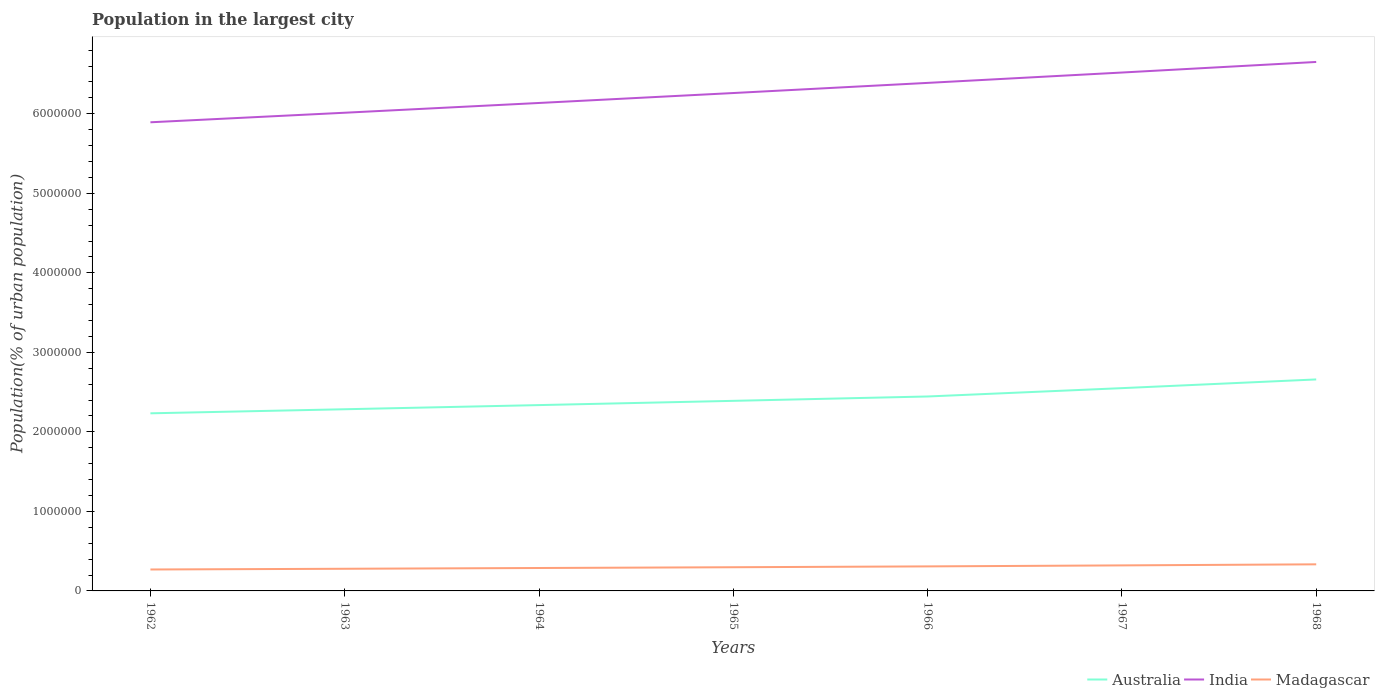Is the number of lines equal to the number of legend labels?
Your response must be concise. Yes. Across all years, what is the maximum population in the largest city in Madagascar?
Provide a short and direct response. 2.70e+05. In which year was the population in the largest city in Madagascar maximum?
Ensure brevity in your answer.  1962. What is the total population in the largest city in Australia in the graph?
Keep it short and to the point. -2.13e+05. What is the difference between the highest and the second highest population in the largest city in Madagascar?
Make the answer very short. 6.49e+04. What is the difference between the highest and the lowest population in the largest city in Australia?
Ensure brevity in your answer.  3. What is the difference between two consecutive major ticks on the Y-axis?
Provide a succinct answer. 1.00e+06. Does the graph contain any zero values?
Give a very brief answer. No. How many legend labels are there?
Your answer should be very brief. 3. What is the title of the graph?
Your response must be concise. Population in the largest city. Does "Sint Maarten (Dutch part)" appear as one of the legend labels in the graph?
Your answer should be compact. No. What is the label or title of the Y-axis?
Your response must be concise. Population(% of urban population). What is the Population(% of urban population) of Australia in 1962?
Offer a terse response. 2.23e+06. What is the Population(% of urban population) in India in 1962?
Your answer should be very brief. 5.89e+06. What is the Population(% of urban population) of Madagascar in 1962?
Offer a very short reply. 2.70e+05. What is the Population(% of urban population) in Australia in 1963?
Your response must be concise. 2.28e+06. What is the Population(% of urban population) of India in 1963?
Your answer should be compact. 6.01e+06. What is the Population(% of urban population) in Madagascar in 1963?
Offer a very short reply. 2.79e+05. What is the Population(% of urban population) in Australia in 1964?
Provide a succinct answer. 2.34e+06. What is the Population(% of urban population) of India in 1964?
Ensure brevity in your answer.  6.14e+06. What is the Population(% of urban population) in Madagascar in 1964?
Keep it short and to the point. 2.88e+05. What is the Population(% of urban population) in Australia in 1965?
Offer a terse response. 2.39e+06. What is the Population(% of urban population) in India in 1965?
Keep it short and to the point. 6.26e+06. What is the Population(% of urban population) in Madagascar in 1965?
Your answer should be compact. 2.98e+05. What is the Population(% of urban population) in Australia in 1966?
Give a very brief answer. 2.45e+06. What is the Population(% of urban population) in India in 1966?
Keep it short and to the point. 6.39e+06. What is the Population(% of urban population) of Madagascar in 1966?
Provide a succinct answer. 3.08e+05. What is the Population(% of urban population) in Australia in 1967?
Keep it short and to the point. 2.55e+06. What is the Population(% of urban population) of India in 1967?
Provide a succinct answer. 6.52e+06. What is the Population(% of urban population) of Madagascar in 1967?
Your response must be concise. 3.21e+05. What is the Population(% of urban population) of Australia in 1968?
Offer a terse response. 2.66e+06. What is the Population(% of urban population) of India in 1968?
Give a very brief answer. 6.65e+06. What is the Population(% of urban population) of Madagascar in 1968?
Your response must be concise. 3.34e+05. Across all years, what is the maximum Population(% of urban population) of Australia?
Offer a very short reply. 2.66e+06. Across all years, what is the maximum Population(% of urban population) in India?
Offer a very short reply. 6.65e+06. Across all years, what is the maximum Population(% of urban population) in Madagascar?
Offer a very short reply. 3.34e+05. Across all years, what is the minimum Population(% of urban population) in Australia?
Offer a terse response. 2.23e+06. Across all years, what is the minimum Population(% of urban population) of India?
Provide a short and direct response. 5.89e+06. Across all years, what is the minimum Population(% of urban population) of Madagascar?
Ensure brevity in your answer.  2.70e+05. What is the total Population(% of urban population) in Australia in the graph?
Offer a very short reply. 1.69e+07. What is the total Population(% of urban population) in India in the graph?
Your answer should be compact. 4.39e+07. What is the total Population(% of urban population) of Madagascar in the graph?
Offer a very short reply. 2.10e+06. What is the difference between the Population(% of urban population) in Australia in 1962 and that in 1963?
Offer a terse response. -5.11e+04. What is the difference between the Population(% of urban population) of India in 1962 and that in 1963?
Your answer should be compact. -1.20e+05. What is the difference between the Population(% of urban population) in Madagascar in 1962 and that in 1963?
Make the answer very short. -9164. What is the difference between the Population(% of urban population) of Australia in 1962 and that in 1964?
Give a very brief answer. -1.03e+05. What is the difference between the Population(% of urban population) in India in 1962 and that in 1964?
Your response must be concise. -2.43e+05. What is the difference between the Population(% of urban population) in Madagascar in 1962 and that in 1964?
Make the answer very short. -1.87e+04. What is the difference between the Population(% of urban population) in Australia in 1962 and that in 1965?
Ensure brevity in your answer.  -1.57e+05. What is the difference between the Population(% of urban population) of India in 1962 and that in 1965?
Your answer should be compact. -3.68e+05. What is the difference between the Population(% of urban population) of Madagascar in 1962 and that in 1965?
Provide a short and direct response. -2.84e+04. What is the difference between the Population(% of urban population) of Australia in 1962 and that in 1966?
Provide a succinct answer. -2.12e+05. What is the difference between the Population(% of urban population) in India in 1962 and that in 1966?
Your answer should be very brief. -4.95e+05. What is the difference between the Population(% of urban population) of Madagascar in 1962 and that in 1966?
Make the answer very short. -3.89e+04. What is the difference between the Population(% of urban population) in Australia in 1962 and that in 1967?
Your response must be concise. -3.16e+05. What is the difference between the Population(% of urban population) of India in 1962 and that in 1967?
Make the answer very short. -6.26e+05. What is the difference between the Population(% of urban population) of Madagascar in 1962 and that in 1967?
Provide a succinct answer. -5.16e+04. What is the difference between the Population(% of urban population) of Australia in 1962 and that in 1968?
Offer a terse response. -4.26e+05. What is the difference between the Population(% of urban population) in India in 1962 and that in 1968?
Ensure brevity in your answer.  -7.59e+05. What is the difference between the Population(% of urban population) of Madagascar in 1962 and that in 1968?
Your answer should be very brief. -6.49e+04. What is the difference between the Population(% of urban population) in Australia in 1963 and that in 1964?
Your answer should be compact. -5.23e+04. What is the difference between the Population(% of urban population) of India in 1963 and that in 1964?
Provide a short and direct response. -1.23e+05. What is the difference between the Population(% of urban population) in Madagascar in 1963 and that in 1964?
Give a very brief answer. -9490. What is the difference between the Population(% of urban population) of Australia in 1963 and that in 1965?
Your response must be concise. -1.06e+05. What is the difference between the Population(% of urban population) in India in 1963 and that in 1965?
Make the answer very short. -2.48e+05. What is the difference between the Population(% of urban population) of Madagascar in 1963 and that in 1965?
Give a very brief answer. -1.93e+04. What is the difference between the Population(% of urban population) in Australia in 1963 and that in 1966?
Provide a short and direct response. -1.60e+05. What is the difference between the Population(% of urban population) in India in 1963 and that in 1966?
Keep it short and to the point. -3.75e+05. What is the difference between the Population(% of urban population) in Madagascar in 1963 and that in 1966?
Make the answer very short. -2.97e+04. What is the difference between the Population(% of urban population) in Australia in 1963 and that in 1967?
Give a very brief answer. -2.65e+05. What is the difference between the Population(% of urban population) in India in 1963 and that in 1967?
Your answer should be compact. -5.05e+05. What is the difference between the Population(% of urban population) in Madagascar in 1963 and that in 1967?
Ensure brevity in your answer.  -4.25e+04. What is the difference between the Population(% of urban population) of Australia in 1963 and that in 1968?
Your answer should be compact. -3.75e+05. What is the difference between the Population(% of urban population) in India in 1963 and that in 1968?
Offer a terse response. -6.39e+05. What is the difference between the Population(% of urban population) in Madagascar in 1963 and that in 1968?
Ensure brevity in your answer.  -5.58e+04. What is the difference between the Population(% of urban population) of Australia in 1964 and that in 1965?
Offer a very short reply. -5.34e+04. What is the difference between the Population(% of urban population) of India in 1964 and that in 1965?
Your response must be concise. -1.25e+05. What is the difference between the Population(% of urban population) of Madagascar in 1964 and that in 1965?
Make the answer very short. -9785. What is the difference between the Population(% of urban population) of Australia in 1964 and that in 1966?
Make the answer very short. -1.08e+05. What is the difference between the Population(% of urban population) of India in 1964 and that in 1966?
Your answer should be very brief. -2.53e+05. What is the difference between the Population(% of urban population) of Madagascar in 1964 and that in 1966?
Give a very brief answer. -2.02e+04. What is the difference between the Population(% of urban population) in Australia in 1964 and that in 1967?
Offer a very short reply. -2.13e+05. What is the difference between the Population(% of urban population) in India in 1964 and that in 1967?
Make the answer very short. -3.83e+05. What is the difference between the Population(% of urban population) in Madagascar in 1964 and that in 1967?
Offer a terse response. -3.30e+04. What is the difference between the Population(% of urban population) of Australia in 1964 and that in 1968?
Give a very brief answer. -3.23e+05. What is the difference between the Population(% of urban population) of India in 1964 and that in 1968?
Provide a short and direct response. -5.16e+05. What is the difference between the Population(% of urban population) of Madagascar in 1964 and that in 1968?
Provide a succinct answer. -4.63e+04. What is the difference between the Population(% of urban population) in Australia in 1965 and that in 1966?
Keep it short and to the point. -5.48e+04. What is the difference between the Population(% of urban population) in India in 1965 and that in 1966?
Offer a very short reply. -1.28e+05. What is the difference between the Population(% of urban population) in Madagascar in 1965 and that in 1966?
Offer a very short reply. -1.04e+04. What is the difference between the Population(% of urban population) of Australia in 1965 and that in 1967?
Keep it short and to the point. -1.60e+05. What is the difference between the Population(% of urban population) of India in 1965 and that in 1967?
Offer a terse response. -2.58e+05. What is the difference between the Population(% of urban population) of Madagascar in 1965 and that in 1967?
Ensure brevity in your answer.  -2.32e+04. What is the difference between the Population(% of urban population) in Australia in 1965 and that in 1968?
Offer a terse response. -2.69e+05. What is the difference between the Population(% of urban population) of India in 1965 and that in 1968?
Make the answer very short. -3.91e+05. What is the difference between the Population(% of urban population) in Madagascar in 1965 and that in 1968?
Ensure brevity in your answer.  -3.65e+04. What is the difference between the Population(% of urban population) in Australia in 1966 and that in 1967?
Offer a terse response. -1.05e+05. What is the difference between the Population(% of urban population) of India in 1966 and that in 1967?
Keep it short and to the point. -1.30e+05. What is the difference between the Population(% of urban population) in Madagascar in 1966 and that in 1967?
Keep it short and to the point. -1.27e+04. What is the difference between the Population(% of urban population) in Australia in 1966 and that in 1968?
Keep it short and to the point. -2.14e+05. What is the difference between the Population(% of urban population) of India in 1966 and that in 1968?
Make the answer very short. -2.63e+05. What is the difference between the Population(% of urban population) of Madagascar in 1966 and that in 1968?
Provide a short and direct response. -2.60e+04. What is the difference between the Population(% of urban population) in Australia in 1967 and that in 1968?
Your response must be concise. -1.10e+05. What is the difference between the Population(% of urban population) of India in 1967 and that in 1968?
Offer a terse response. -1.33e+05. What is the difference between the Population(% of urban population) of Madagascar in 1967 and that in 1968?
Your response must be concise. -1.33e+04. What is the difference between the Population(% of urban population) of Australia in 1962 and the Population(% of urban population) of India in 1963?
Provide a succinct answer. -3.78e+06. What is the difference between the Population(% of urban population) of Australia in 1962 and the Population(% of urban population) of Madagascar in 1963?
Your answer should be very brief. 1.95e+06. What is the difference between the Population(% of urban population) in India in 1962 and the Population(% of urban population) in Madagascar in 1963?
Provide a short and direct response. 5.61e+06. What is the difference between the Population(% of urban population) in Australia in 1962 and the Population(% of urban population) in India in 1964?
Ensure brevity in your answer.  -3.90e+06. What is the difference between the Population(% of urban population) in Australia in 1962 and the Population(% of urban population) in Madagascar in 1964?
Make the answer very short. 1.95e+06. What is the difference between the Population(% of urban population) of India in 1962 and the Population(% of urban population) of Madagascar in 1964?
Ensure brevity in your answer.  5.61e+06. What is the difference between the Population(% of urban population) of Australia in 1962 and the Population(% of urban population) of India in 1965?
Your answer should be very brief. -4.03e+06. What is the difference between the Population(% of urban population) of Australia in 1962 and the Population(% of urban population) of Madagascar in 1965?
Give a very brief answer. 1.94e+06. What is the difference between the Population(% of urban population) in India in 1962 and the Population(% of urban population) in Madagascar in 1965?
Offer a terse response. 5.60e+06. What is the difference between the Population(% of urban population) of Australia in 1962 and the Population(% of urban population) of India in 1966?
Keep it short and to the point. -4.16e+06. What is the difference between the Population(% of urban population) of Australia in 1962 and the Population(% of urban population) of Madagascar in 1966?
Offer a very short reply. 1.93e+06. What is the difference between the Population(% of urban population) in India in 1962 and the Population(% of urban population) in Madagascar in 1966?
Offer a terse response. 5.58e+06. What is the difference between the Population(% of urban population) of Australia in 1962 and the Population(% of urban population) of India in 1967?
Your answer should be very brief. -4.29e+06. What is the difference between the Population(% of urban population) of Australia in 1962 and the Population(% of urban population) of Madagascar in 1967?
Ensure brevity in your answer.  1.91e+06. What is the difference between the Population(% of urban population) of India in 1962 and the Population(% of urban population) of Madagascar in 1967?
Offer a very short reply. 5.57e+06. What is the difference between the Population(% of urban population) of Australia in 1962 and the Population(% of urban population) of India in 1968?
Offer a terse response. -4.42e+06. What is the difference between the Population(% of urban population) of Australia in 1962 and the Population(% of urban population) of Madagascar in 1968?
Make the answer very short. 1.90e+06. What is the difference between the Population(% of urban population) of India in 1962 and the Population(% of urban population) of Madagascar in 1968?
Your answer should be very brief. 5.56e+06. What is the difference between the Population(% of urban population) in Australia in 1963 and the Population(% of urban population) in India in 1964?
Your response must be concise. -3.85e+06. What is the difference between the Population(% of urban population) in Australia in 1963 and the Population(% of urban population) in Madagascar in 1964?
Provide a succinct answer. 2.00e+06. What is the difference between the Population(% of urban population) in India in 1963 and the Population(% of urban population) in Madagascar in 1964?
Your answer should be very brief. 5.73e+06. What is the difference between the Population(% of urban population) of Australia in 1963 and the Population(% of urban population) of India in 1965?
Your answer should be compact. -3.98e+06. What is the difference between the Population(% of urban population) of Australia in 1963 and the Population(% of urban population) of Madagascar in 1965?
Keep it short and to the point. 1.99e+06. What is the difference between the Population(% of urban population) in India in 1963 and the Population(% of urban population) in Madagascar in 1965?
Make the answer very short. 5.72e+06. What is the difference between the Population(% of urban population) in Australia in 1963 and the Population(% of urban population) in India in 1966?
Provide a succinct answer. -4.10e+06. What is the difference between the Population(% of urban population) of Australia in 1963 and the Population(% of urban population) of Madagascar in 1966?
Make the answer very short. 1.98e+06. What is the difference between the Population(% of urban population) in India in 1963 and the Population(% of urban population) in Madagascar in 1966?
Give a very brief answer. 5.70e+06. What is the difference between the Population(% of urban population) of Australia in 1963 and the Population(% of urban population) of India in 1967?
Keep it short and to the point. -4.23e+06. What is the difference between the Population(% of urban population) of Australia in 1963 and the Population(% of urban population) of Madagascar in 1967?
Give a very brief answer. 1.96e+06. What is the difference between the Population(% of urban population) of India in 1963 and the Population(% of urban population) of Madagascar in 1967?
Your answer should be compact. 5.69e+06. What is the difference between the Population(% of urban population) of Australia in 1963 and the Population(% of urban population) of India in 1968?
Offer a very short reply. -4.37e+06. What is the difference between the Population(% of urban population) in Australia in 1963 and the Population(% of urban population) in Madagascar in 1968?
Ensure brevity in your answer.  1.95e+06. What is the difference between the Population(% of urban population) of India in 1963 and the Population(% of urban population) of Madagascar in 1968?
Provide a succinct answer. 5.68e+06. What is the difference between the Population(% of urban population) in Australia in 1964 and the Population(% of urban population) in India in 1965?
Keep it short and to the point. -3.92e+06. What is the difference between the Population(% of urban population) in Australia in 1964 and the Population(% of urban population) in Madagascar in 1965?
Your answer should be very brief. 2.04e+06. What is the difference between the Population(% of urban population) in India in 1964 and the Population(% of urban population) in Madagascar in 1965?
Provide a short and direct response. 5.84e+06. What is the difference between the Population(% of urban population) in Australia in 1964 and the Population(% of urban population) in India in 1966?
Your answer should be very brief. -4.05e+06. What is the difference between the Population(% of urban population) in Australia in 1964 and the Population(% of urban population) in Madagascar in 1966?
Offer a terse response. 2.03e+06. What is the difference between the Population(% of urban population) of India in 1964 and the Population(% of urban population) of Madagascar in 1966?
Your answer should be compact. 5.83e+06. What is the difference between the Population(% of urban population) of Australia in 1964 and the Population(% of urban population) of India in 1967?
Make the answer very short. -4.18e+06. What is the difference between the Population(% of urban population) in Australia in 1964 and the Population(% of urban population) in Madagascar in 1967?
Provide a succinct answer. 2.02e+06. What is the difference between the Population(% of urban population) in India in 1964 and the Population(% of urban population) in Madagascar in 1967?
Give a very brief answer. 5.81e+06. What is the difference between the Population(% of urban population) of Australia in 1964 and the Population(% of urban population) of India in 1968?
Offer a terse response. -4.32e+06. What is the difference between the Population(% of urban population) of Australia in 1964 and the Population(% of urban population) of Madagascar in 1968?
Offer a terse response. 2.00e+06. What is the difference between the Population(% of urban population) in India in 1964 and the Population(% of urban population) in Madagascar in 1968?
Your answer should be compact. 5.80e+06. What is the difference between the Population(% of urban population) of Australia in 1965 and the Population(% of urban population) of India in 1966?
Ensure brevity in your answer.  -4.00e+06. What is the difference between the Population(% of urban population) of Australia in 1965 and the Population(% of urban population) of Madagascar in 1966?
Offer a terse response. 2.08e+06. What is the difference between the Population(% of urban population) of India in 1965 and the Population(% of urban population) of Madagascar in 1966?
Give a very brief answer. 5.95e+06. What is the difference between the Population(% of urban population) of Australia in 1965 and the Population(% of urban population) of India in 1967?
Make the answer very short. -4.13e+06. What is the difference between the Population(% of urban population) of Australia in 1965 and the Population(% of urban population) of Madagascar in 1967?
Your answer should be very brief. 2.07e+06. What is the difference between the Population(% of urban population) of India in 1965 and the Population(% of urban population) of Madagascar in 1967?
Your answer should be compact. 5.94e+06. What is the difference between the Population(% of urban population) in Australia in 1965 and the Population(% of urban population) in India in 1968?
Give a very brief answer. -4.26e+06. What is the difference between the Population(% of urban population) of Australia in 1965 and the Population(% of urban population) of Madagascar in 1968?
Offer a very short reply. 2.06e+06. What is the difference between the Population(% of urban population) in India in 1965 and the Population(% of urban population) in Madagascar in 1968?
Your answer should be very brief. 5.93e+06. What is the difference between the Population(% of urban population) in Australia in 1966 and the Population(% of urban population) in India in 1967?
Keep it short and to the point. -4.07e+06. What is the difference between the Population(% of urban population) in Australia in 1966 and the Population(% of urban population) in Madagascar in 1967?
Provide a succinct answer. 2.12e+06. What is the difference between the Population(% of urban population) in India in 1966 and the Population(% of urban population) in Madagascar in 1967?
Make the answer very short. 6.07e+06. What is the difference between the Population(% of urban population) of Australia in 1966 and the Population(% of urban population) of India in 1968?
Offer a very short reply. -4.21e+06. What is the difference between the Population(% of urban population) in Australia in 1966 and the Population(% of urban population) in Madagascar in 1968?
Your response must be concise. 2.11e+06. What is the difference between the Population(% of urban population) of India in 1966 and the Population(% of urban population) of Madagascar in 1968?
Your answer should be compact. 6.05e+06. What is the difference between the Population(% of urban population) of Australia in 1967 and the Population(% of urban population) of India in 1968?
Keep it short and to the point. -4.10e+06. What is the difference between the Population(% of urban population) of Australia in 1967 and the Population(% of urban population) of Madagascar in 1968?
Provide a succinct answer. 2.22e+06. What is the difference between the Population(% of urban population) of India in 1967 and the Population(% of urban population) of Madagascar in 1968?
Keep it short and to the point. 6.18e+06. What is the average Population(% of urban population) of Australia per year?
Offer a terse response. 2.41e+06. What is the average Population(% of urban population) in India per year?
Ensure brevity in your answer.  6.27e+06. What is the average Population(% of urban population) of Madagascar per year?
Your response must be concise. 3.00e+05. In the year 1962, what is the difference between the Population(% of urban population) of Australia and Population(% of urban population) of India?
Make the answer very short. -3.66e+06. In the year 1962, what is the difference between the Population(% of urban population) of Australia and Population(% of urban population) of Madagascar?
Ensure brevity in your answer.  1.96e+06. In the year 1962, what is the difference between the Population(% of urban population) of India and Population(% of urban population) of Madagascar?
Provide a short and direct response. 5.62e+06. In the year 1963, what is the difference between the Population(% of urban population) of Australia and Population(% of urban population) of India?
Offer a very short reply. -3.73e+06. In the year 1963, what is the difference between the Population(% of urban population) in Australia and Population(% of urban population) in Madagascar?
Give a very brief answer. 2.01e+06. In the year 1963, what is the difference between the Population(% of urban population) of India and Population(% of urban population) of Madagascar?
Provide a succinct answer. 5.73e+06. In the year 1964, what is the difference between the Population(% of urban population) in Australia and Population(% of urban population) in India?
Offer a very short reply. -3.80e+06. In the year 1964, what is the difference between the Population(% of urban population) of Australia and Population(% of urban population) of Madagascar?
Ensure brevity in your answer.  2.05e+06. In the year 1964, what is the difference between the Population(% of urban population) in India and Population(% of urban population) in Madagascar?
Give a very brief answer. 5.85e+06. In the year 1965, what is the difference between the Population(% of urban population) of Australia and Population(% of urban population) of India?
Ensure brevity in your answer.  -3.87e+06. In the year 1965, what is the difference between the Population(% of urban population) in Australia and Population(% of urban population) in Madagascar?
Ensure brevity in your answer.  2.09e+06. In the year 1965, what is the difference between the Population(% of urban population) in India and Population(% of urban population) in Madagascar?
Your answer should be compact. 5.96e+06. In the year 1966, what is the difference between the Population(% of urban population) in Australia and Population(% of urban population) in India?
Ensure brevity in your answer.  -3.94e+06. In the year 1966, what is the difference between the Population(% of urban population) in Australia and Population(% of urban population) in Madagascar?
Give a very brief answer. 2.14e+06. In the year 1966, what is the difference between the Population(% of urban population) in India and Population(% of urban population) in Madagascar?
Make the answer very short. 6.08e+06. In the year 1967, what is the difference between the Population(% of urban population) in Australia and Population(% of urban population) in India?
Offer a very short reply. -3.97e+06. In the year 1967, what is the difference between the Population(% of urban population) in Australia and Population(% of urban population) in Madagascar?
Your response must be concise. 2.23e+06. In the year 1967, what is the difference between the Population(% of urban population) of India and Population(% of urban population) of Madagascar?
Your answer should be very brief. 6.20e+06. In the year 1968, what is the difference between the Population(% of urban population) of Australia and Population(% of urban population) of India?
Keep it short and to the point. -3.99e+06. In the year 1968, what is the difference between the Population(% of urban population) in Australia and Population(% of urban population) in Madagascar?
Make the answer very short. 2.33e+06. In the year 1968, what is the difference between the Population(% of urban population) of India and Population(% of urban population) of Madagascar?
Make the answer very short. 6.32e+06. What is the ratio of the Population(% of urban population) of Australia in 1962 to that in 1963?
Provide a short and direct response. 0.98. What is the ratio of the Population(% of urban population) of India in 1962 to that in 1963?
Ensure brevity in your answer.  0.98. What is the ratio of the Population(% of urban population) in Madagascar in 1962 to that in 1963?
Keep it short and to the point. 0.97. What is the ratio of the Population(% of urban population) of Australia in 1962 to that in 1964?
Your answer should be compact. 0.96. What is the ratio of the Population(% of urban population) of India in 1962 to that in 1964?
Your response must be concise. 0.96. What is the ratio of the Population(% of urban population) of Madagascar in 1962 to that in 1964?
Offer a terse response. 0.94. What is the ratio of the Population(% of urban population) of Australia in 1962 to that in 1965?
Offer a very short reply. 0.93. What is the ratio of the Population(% of urban population) of India in 1962 to that in 1965?
Provide a short and direct response. 0.94. What is the ratio of the Population(% of urban population) of Madagascar in 1962 to that in 1965?
Offer a terse response. 0.9. What is the ratio of the Population(% of urban population) of Australia in 1962 to that in 1966?
Keep it short and to the point. 0.91. What is the ratio of the Population(% of urban population) of India in 1962 to that in 1966?
Provide a short and direct response. 0.92. What is the ratio of the Population(% of urban population) in Madagascar in 1962 to that in 1966?
Keep it short and to the point. 0.87. What is the ratio of the Population(% of urban population) in Australia in 1962 to that in 1967?
Your answer should be compact. 0.88. What is the ratio of the Population(% of urban population) in India in 1962 to that in 1967?
Your answer should be compact. 0.9. What is the ratio of the Population(% of urban population) in Madagascar in 1962 to that in 1967?
Your response must be concise. 0.84. What is the ratio of the Population(% of urban population) of Australia in 1962 to that in 1968?
Your response must be concise. 0.84. What is the ratio of the Population(% of urban population) in India in 1962 to that in 1968?
Offer a terse response. 0.89. What is the ratio of the Population(% of urban population) in Madagascar in 1962 to that in 1968?
Keep it short and to the point. 0.81. What is the ratio of the Population(% of urban population) in Australia in 1963 to that in 1964?
Your response must be concise. 0.98. What is the ratio of the Population(% of urban population) in Madagascar in 1963 to that in 1964?
Your answer should be very brief. 0.97. What is the ratio of the Population(% of urban population) in Australia in 1963 to that in 1965?
Your response must be concise. 0.96. What is the ratio of the Population(% of urban population) in India in 1963 to that in 1965?
Your answer should be compact. 0.96. What is the ratio of the Population(% of urban population) of Madagascar in 1963 to that in 1965?
Provide a succinct answer. 0.94. What is the ratio of the Population(% of urban population) in Australia in 1963 to that in 1966?
Provide a short and direct response. 0.93. What is the ratio of the Population(% of urban population) of India in 1963 to that in 1966?
Provide a short and direct response. 0.94. What is the ratio of the Population(% of urban population) of Madagascar in 1963 to that in 1966?
Provide a succinct answer. 0.9. What is the ratio of the Population(% of urban population) of Australia in 1963 to that in 1967?
Offer a very short reply. 0.9. What is the ratio of the Population(% of urban population) of India in 1963 to that in 1967?
Your answer should be very brief. 0.92. What is the ratio of the Population(% of urban population) of Madagascar in 1963 to that in 1967?
Your answer should be compact. 0.87. What is the ratio of the Population(% of urban population) in Australia in 1963 to that in 1968?
Your answer should be compact. 0.86. What is the ratio of the Population(% of urban population) in India in 1963 to that in 1968?
Provide a succinct answer. 0.9. What is the ratio of the Population(% of urban population) in Australia in 1964 to that in 1965?
Your answer should be compact. 0.98. What is the ratio of the Population(% of urban population) of India in 1964 to that in 1965?
Offer a very short reply. 0.98. What is the ratio of the Population(% of urban population) in Madagascar in 1964 to that in 1965?
Provide a short and direct response. 0.97. What is the ratio of the Population(% of urban population) in Australia in 1964 to that in 1966?
Your response must be concise. 0.96. What is the ratio of the Population(% of urban population) in India in 1964 to that in 1966?
Your answer should be compact. 0.96. What is the ratio of the Population(% of urban population) in Madagascar in 1964 to that in 1966?
Provide a short and direct response. 0.93. What is the ratio of the Population(% of urban population) of Australia in 1964 to that in 1967?
Your response must be concise. 0.92. What is the ratio of the Population(% of urban population) of India in 1964 to that in 1967?
Give a very brief answer. 0.94. What is the ratio of the Population(% of urban population) of Madagascar in 1964 to that in 1967?
Provide a short and direct response. 0.9. What is the ratio of the Population(% of urban population) in Australia in 1964 to that in 1968?
Your response must be concise. 0.88. What is the ratio of the Population(% of urban population) in India in 1964 to that in 1968?
Make the answer very short. 0.92. What is the ratio of the Population(% of urban population) in Madagascar in 1964 to that in 1968?
Your answer should be compact. 0.86. What is the ratio of the Population(% of urban population) in Australia in 1965 to that in 1966?
Keep it short and to the point. 0.98. What is the ratio of the Population(% of urban population) in India in 1965 to that in 1966?
Provide a succinct answer. 0.98. What is the ratio of the Population(% of urban population) of Madagascar in 1965 to that in 1966?
Provide a short and direct response. 0.97. What is the ratio of the Population(% of urban population) in Australia in 1965 to that in 1967?
Provide a succinct answer. 0.94. What is the ratio of the Population(% of urban population) of India in 1965 to that in 1967?
Your answer should be very brief. 0.96. What is the ratio of the Population(% of urban population) in Madagascar in 1965 to that in 1967?
Provide a succinct answer. 0.93. What is the ratio of the Population(% of urban population) in Australia in 1965 to that in 1968?
Your answer should be compact. 0.9. What is the ratio of the Population(% of urban population) of Madagascar in 1965 to that in 1968?
Your answer should be very brief. 0.89. What is the ratio of the Population(% of urban population) in Australia in 1966 to that in 1967?
Offer a very short reply. 0.96. What is the ratio of the Population(% of urban population) of Madagascar in 1966 to that in 1967?
Provide a succinct answer. 0.96. What is the ratio of the Population(% of urban population) in Australia in 1966 to that in 1968?
Give a very brief answer. 0.92. What is the ratio of the Population(% of urban population) in India in 1966 to that in 1968?
Ensure brevity in your answer.  0.96. What is the ratio of the Population(% of urban population) in Madagascar in 1966 to that in 1968?
Make the answer very short. 0.92. What is the ratio of the Population(% of urban population) in Australia in 1967 to that in 1968?
Make the answer very short. 0.96. What is the ratio of the Population(% of urban population) in Madagascar in 1967 to that in 1968?
Your answer should be very brief. 0.96. What is the difference between the highest and the second highest Population(% of urban population) in Australia?
Make the answer very short. 1.10e+05. What is the difference between the highest and the second highest Population(% of urban population) in India?
Provide a short and direct response. 1.33e+05. What is the difference between the highest and the second highest Population(% of urban population) in Madagascar?
Your response must be concise. 1.33e+04. What is the difference between the highest and the lowest Population(% of urban population) of Australia?
Give a very brief answer. 4.26e+05. What is the difference between the highest and the lowest Population(% of urban population) of India?
Your answer should be very brief. 7.59e+05. What is the difference between the highest and the lowest Population(% of urban population) in Madagascar?
Provide a short and direct response. 6.49e+04. 